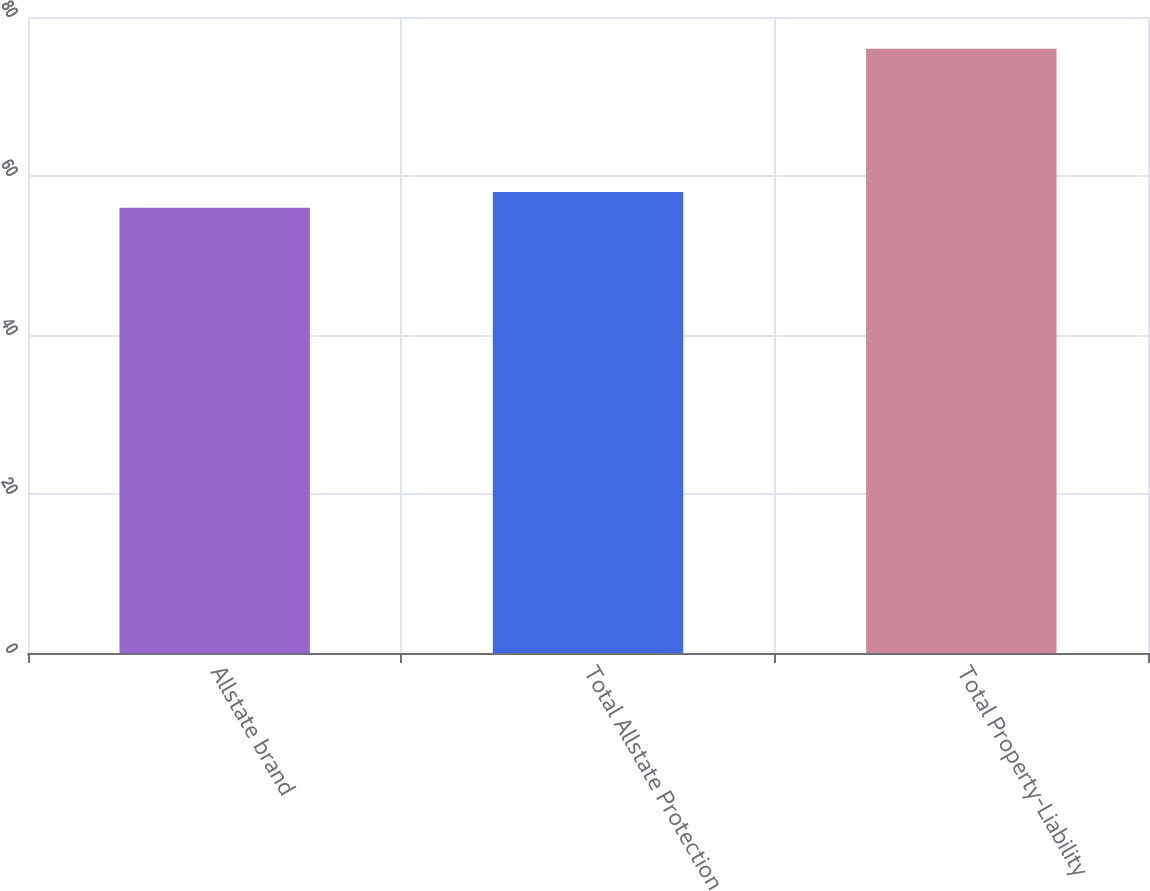Convert chart. <chart><loc_0><loc_0><loc_500><loc_500><bar_chart><fcel>Allstate brand<fcel>Total Allstate Protection<fcel>Total Property-Liability<nl><fcel>56<fcel>58<fcel>76<nl></chart> 